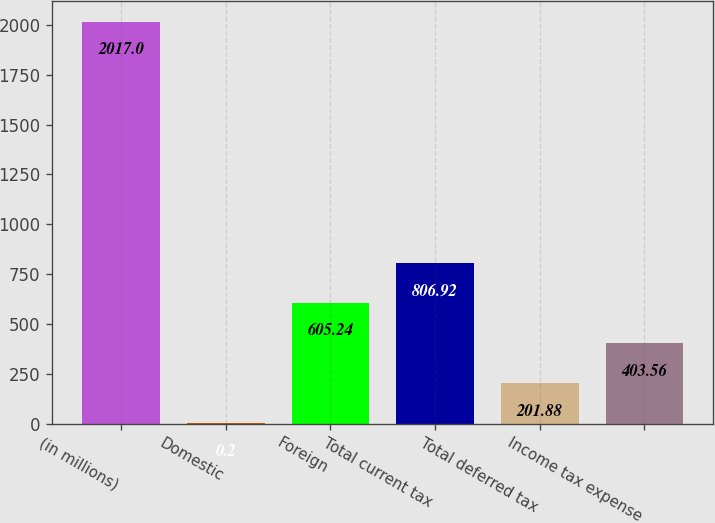Convert chart. <chart><loc_0><loc_0><loc_500><loc_500><bar_chart><fcel>(in millions)<fcel>Domestic<fcel>Foreign<fcel>Total current tax<fcel>Total deferred tax<fcel>Income tax expense<nl><fcel>2017<fcel>0.2<fcel>605.24<fcel>806.92<fcel>201.88<fcel>403.56<nl></chart> 